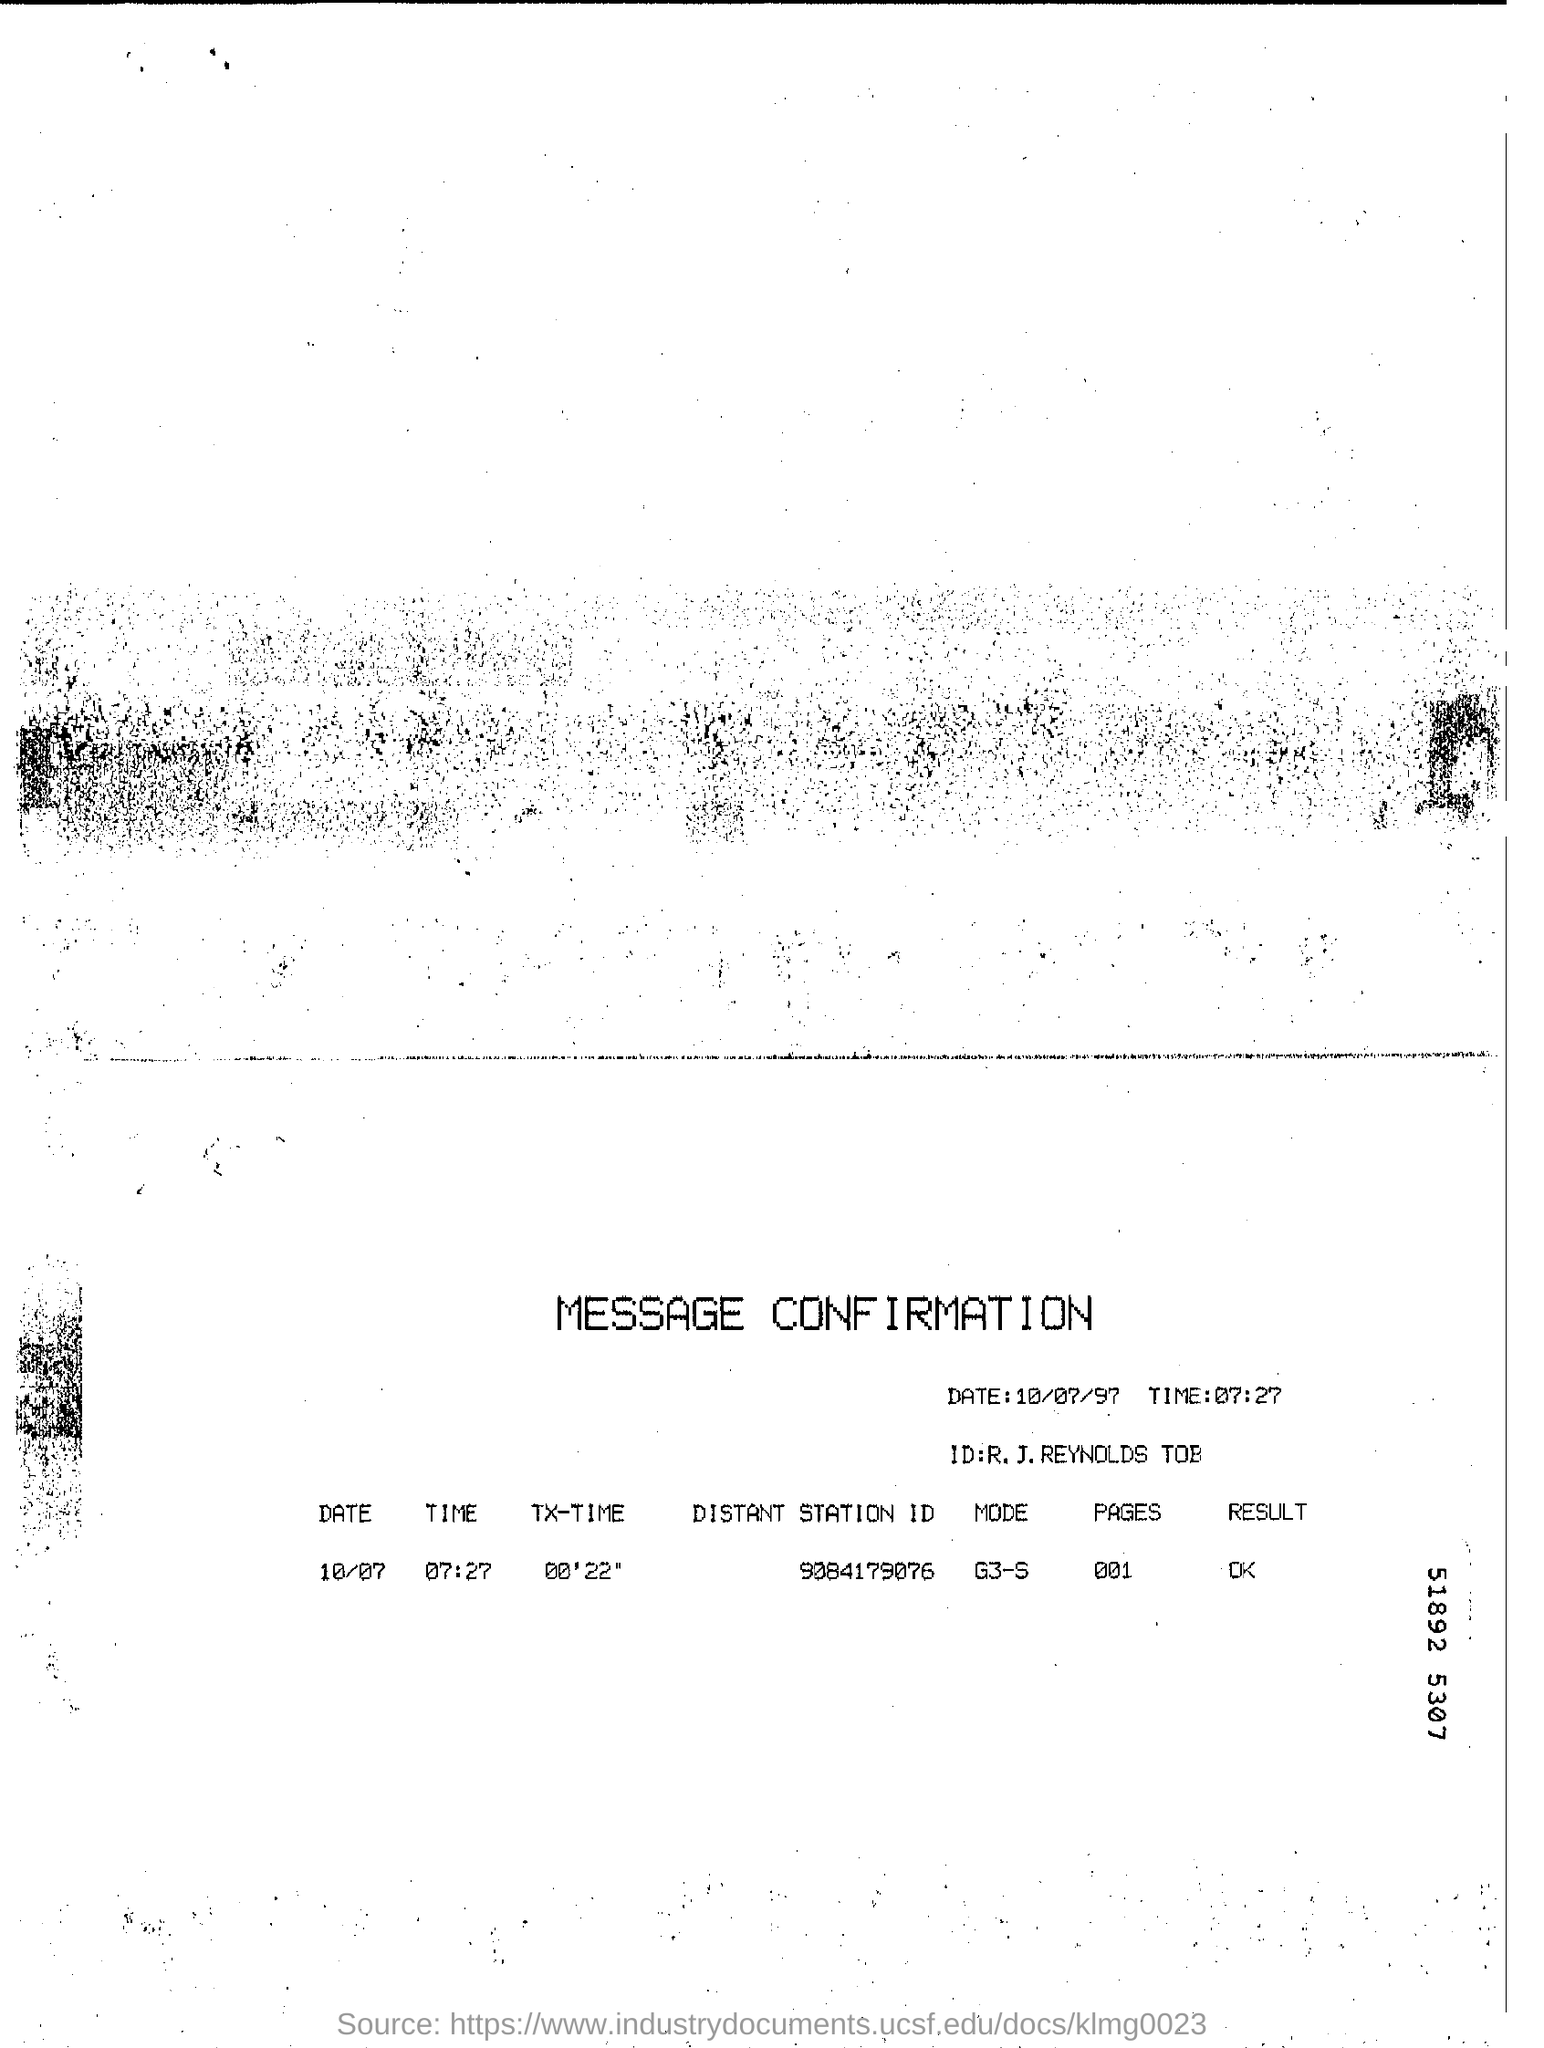Give some essential details in this illustration. The Distant Station ID mentioned in the document is 9084179076. This is a message confirmation document. The date mentioned in this document is 10/07/97. What is the TX-TIME mentioned in the document? It is 00'22". 